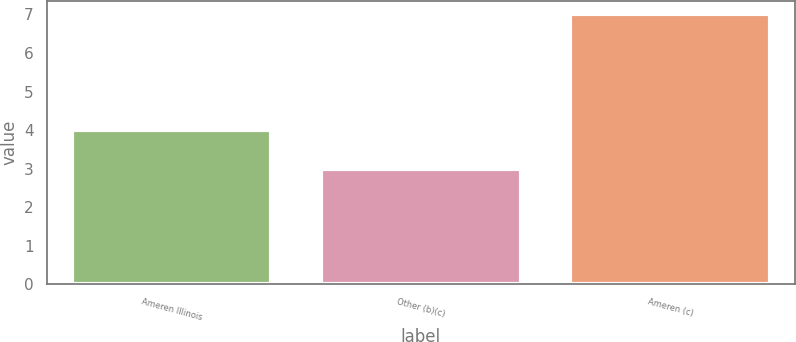Convert chart. <chart><loc_0><loc_0><loc_500><loc_500><bar_chart><fcel>Ameren Illinois<fcel>Other (b)(c)<fcel>Ameren (c)<nl><fcel>4<fcel>3<fcel>7<nl></chart> 